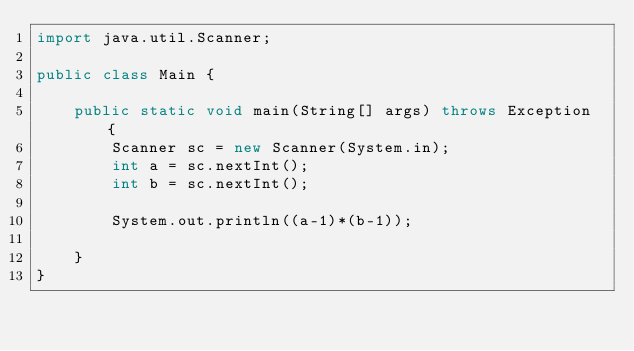<code> <loc_0><loc_0><loc_500><loc_500><_Java_>import java.util.Scanner;

public class Main {

	public static void main(String[] args) throws Exception {
		Scanner sc = new Scanner(System.in);
		int a = sc.nextInt();
		int b = sc.nextInt();
		
		System.out.println((a-1)*(b-1));
		
	}
}</code> 